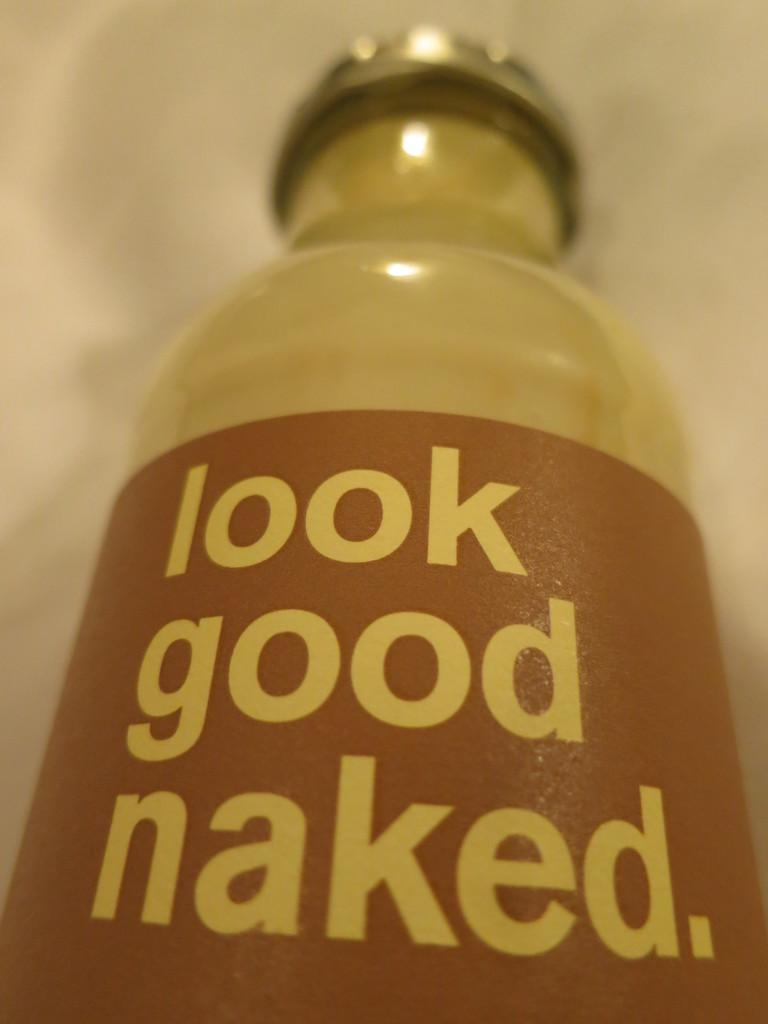<image>
Render a clear and concise summary of the photo. a bottle with a brown label on it that says 'look good naked' 